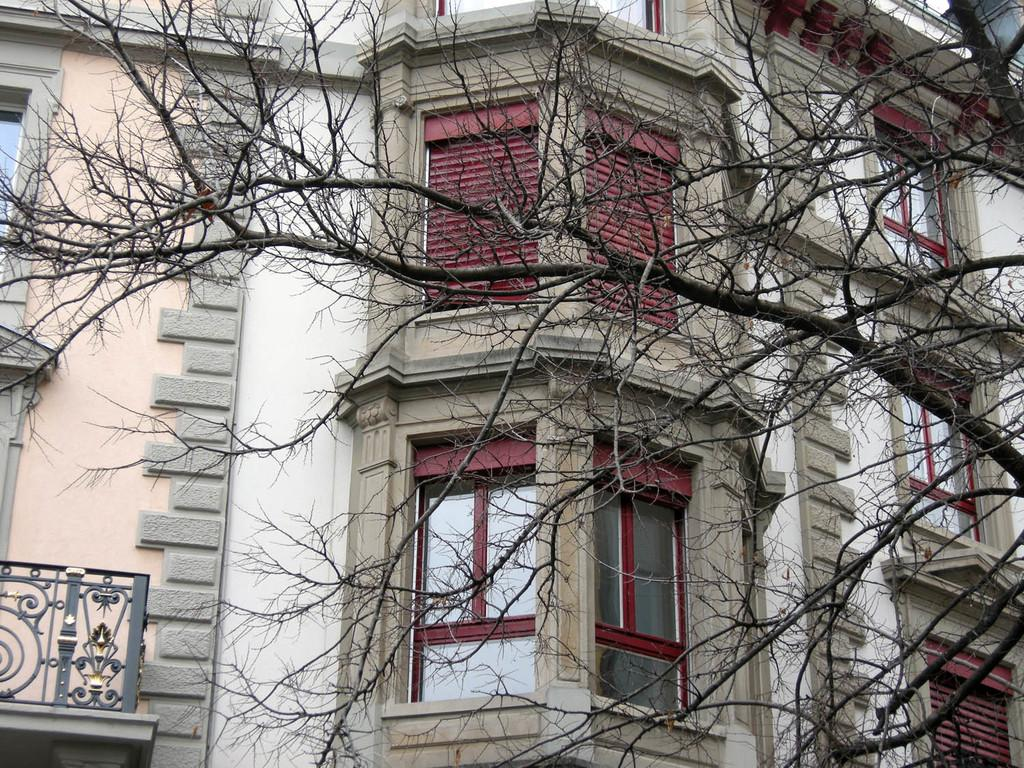What is located in the foreground of the image? There is a tree in the foreground of the image. What type of structure can be seen in the image? There is a building in the image. What feature of the building is mentioned in the facts? The building has windows. Where is the fireman located in the image? There is no fireman present in the image. What type of field can be seen in the image? There is no field present in the image. 